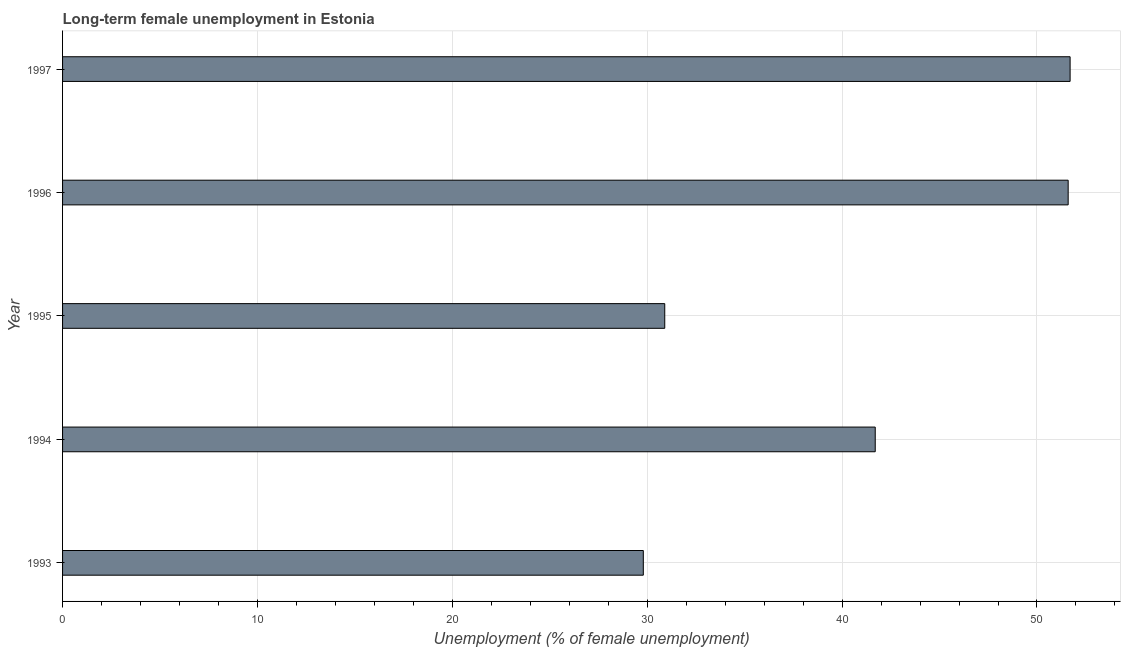Does the graph contain grids?
Make the answer very short. Yes. What is the title of the graph?
Your answer should be compact. Long-term female unemployment in Estonia. What is the label or title of the X-axis?
Offer a terse response. Unemployment (% of female unemployment). What is the long-term female unemployment in 1995?
Provide a short and direct response. 30.9. Across all years, what is the maximum long-term female unemployment?
Offer a terse response. 51.7. Across all years, what is the minimum long-term female unemployment?
Your answer should be compact. 29.8. In which year was the long-term female unemployment minimum?
Make the answer very short. 1993. What is the sum of the long-term female unemployment?
Offer a terse response. 205.7. What is the difference between the long-term female unemployment in 1995 and 1996?
Keep it short and to the point. -20.7. What is the average long-term female unemployment per year?
Your response must be concise. 41.14. What is the median long-term female unemployment?
Offer a very short reply. 41.7. What is the ratio of the long-term female unemployment in 1995 to that in 1996?
Provide a succinct answer. 0.6. Is the sum of the long-term female unemployment in 1994 and 1996 greater than the maximum long-term female unemployment across all years?
Keep it short and to the point. Yes. What is the difference between the highest and the lowest long-term female unemployment?
Provide a succinct answer. 21.9. In how many years, is the long-term female unemployment greater than the average long-term female unemployment taken over all years?
Offer a terse response. 3. How many bars are there?
Provide a short and direct response. 5. What is the Unemployment (% of female unemployment) in 1993?
Offer a terse response. 29.8. What is the Unemployment (% of female unemployment) of 1994?
Your response must be concise. 41.7. What is the Unemployment (% of female unemployment) of 1995?
Keep it short and to the point. 30.9. What is the Unemployment (% of female unemployment) of 1996?
Offer a terse response. 51.6. What is the Unemployment (% of female unemployment) of 1997?
Provide a short and direct response. 51.7. What is the difference between the Unemployment (% of female unemployment) in 1993 and 1995?
Make the answer very short. -1.1. What is the difference between the Unemployment (% of female unemployment) in 1993 and 1996?
Keep it short and to the point. -21.8. What is the difference between the Unemployment (% of female unemployment) in 1993 and 1997?
Ensure brevity in your answer.  -21.9. What is the difference between the Unemployment (% of female unemployment) in 1994 and 1996?
Ensure brevity in your answer.  -9.9. What is the difference between the Unemployment (% of female unemployment) in 1995 and 1996?
Offer a very short reply. -20.7. What is the difference between the Unemployment (% of female unemployment) in 1995 and 1997?
Provide a succinct answer. -20.8. What is the ratio of the Unemployment (% of female unemployment) in 1993 to that in 1994?
Ensure brevity in your answer.  0.71. What is the ratio of the Unemployment (% of female unemployment) in 1993 to that in 1995?
Ensure brevity in your answer.  0.96. What is the ratio of the Unemployment (% of female unemployment) in 1993 to that in 1996?
Keep it short and to the point. 0.58. What is the ratio of the Unemployment (% of female unemployment) in 1993 to that in 1997?
Provide a short and direct response. 0.58. What is the ratio of the Unemployment (% of female unemployment) in 1994 to that in 1995?
Provide a succinct answer. 1.35. What is the ratio of the Unemployment (% of female unemployment) in 1994 to that in 1996?
Provide a short and direct response. 0.81. What is the ratio of the Unemployment (% of female unemployment) in 1994 to that in 1997?
Your answer should be compact. 0.81. What is the ratio of the Unemployment (% of female unemployment) in 1995 to that in 1996?
Ensure brevity in your answer.  0.6. What is the ratio of the Unemployment (% of female unemployment) in 1995 to that in 1997?
Your response must be concise. 0.6. 